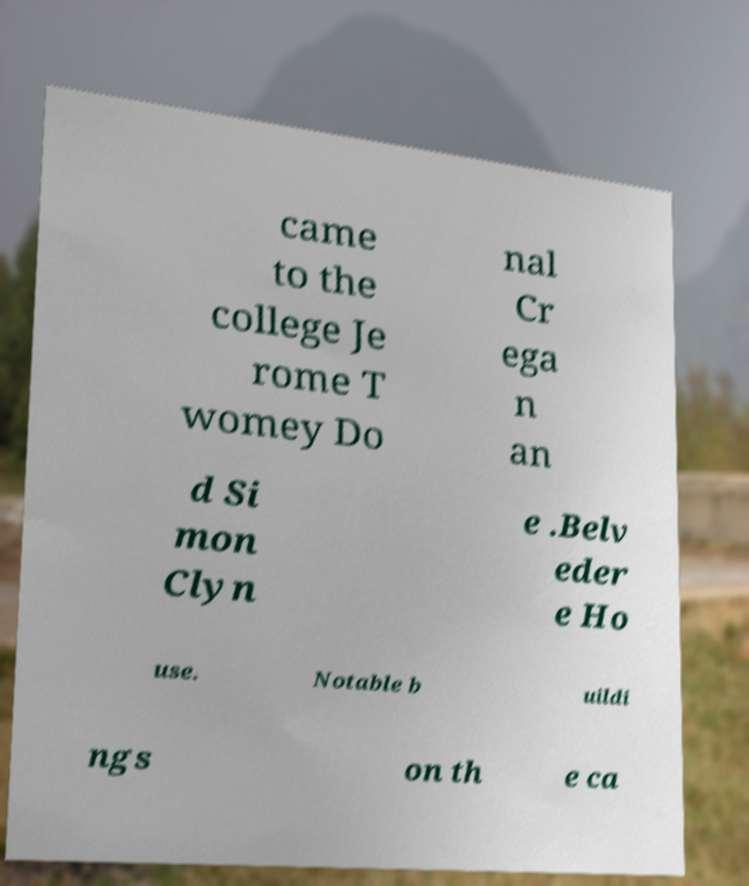What messages or text are displayed in this image? I need them in a readable, typed format. came to the college Je rome T womey Do nal Cr ega n an d Si mon Clyn e .Belv eder e Ho use. Notable b uildi ngs on th e ca 